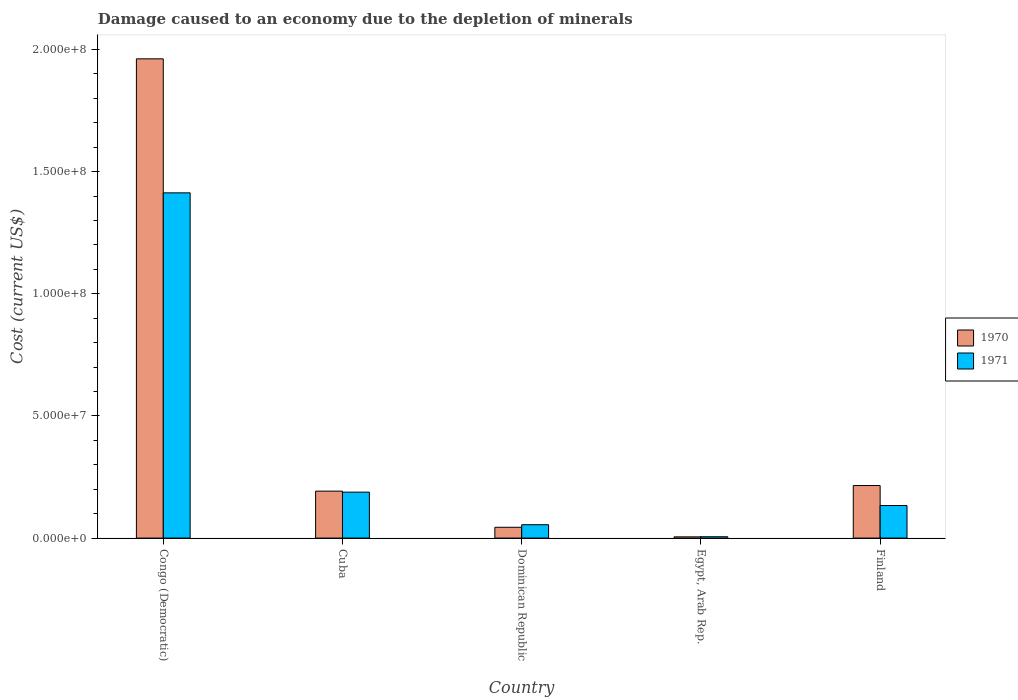Are the number of bars per tick equal to the number of legend labels?
Provide a succinct answer. Yes. Are the number of bars on each tick of the X-axis equal?
Ensure brevity in your answer.  Yes. How many bars are there on the 5th tick from the left?
Keep it short and to the point. 2. How many bars are there on the 2nd tick from the right?
Your answer should be very brief. 2. What is the label of the 5th group of bars from the left?
Ensure brevity in your answer.  Finland. What is the cost of damage caused due to the depletion of minerals in 1970 in Egypt, Arab Rep.?
Your answer should be compact. 5.07e+05. Across all countries, what is the maximum cost of damage caused due to the depletion of minerals in 1971?
Your response must be concise. 1.41e+08. Across all countries, what is the minimum cost of damage caused due to the depletion of minerals in 1970?
Your answer should be very brief. 5.07e+05. In which country was the cost of damage caused due to the depletion of minerals in 1971 maximum?
Make the answer very short. Congo (Democratic). In which country was the cost of damage caused due to the depletion of minerals in 1970 minimum?
Ensure brevity in your answer.  Egypt, Arab Rep. What is the total cost of damage caused due to the depletion of minerals in 1971 in the graph?
Provide a succinct answer. 1.79e+08. What is the difference between the cost of damage caused due to the depletion of minerals in 1970 in Cuba and that in Egypt, Arab Rep.?
Your answer should be compact. 1.87e+07. What is the difference between the cost of damage caused due to the depletion of minerals in 1971 in Congo (Democratic) and the cost of damage caused due to the depletion of minerals in 1970 in Egypt, Arab Rep.?
Ensure brevity in your answer.  1.41e+08. What is the average cost of damage caused due to the depletion of minerals in 1970 per country?
Make the answer very short. 4.84e+07. What is the difference between the cost of damage caused due to the depletion of minerals of/in 1970 and cost of damage caused due to the depletion of minerals of/in 1971 in Egypt, Arab Rep.?
Your answer should be very brief. -4.79e+04. What is the ratio of the cost of damage caused due to the depletion of minerals in 1970 in Egypt, Arab Rep. to that in Finland?
Offer a very short reply. 0.02. Is the cost of damage caused due to the depletion of minerals in 1971 in Congo (Democratic) less than that in Dominican Republic?
Your answer should be compact. No. What is the difference between the highest and the second highest cost of damage caused due to the depletion of minerals in 1971?
Make the answer very short. -1.28e+08. What is the difference between the highest and the lowest cost of damage caused due to the depletion of minerals in 1970?
Keep it short and to the point. 1.96e+08. Is the sum of the cost of damage caused due to the depletion of minerals in 1971 in Congo (Democratic) and Cuba greater than the maximum cost of damage caused due to the depletion of minerals in 1970 across all countries?
Provide a succinct answer. No. How many bars are there?
Offer a terse response. 10. What is the difference between two consecutive major ticks on the Y-axis?
Give a very brief answer. 5.00e+07. What is the title of the graph?
Your response must be concise. Damage caused to an economy due to the depletion of minerals. What is the label or title of the X-axis?
Your response must be concise. Country. What is the label or title of the Y-axis?
Give a very brief answer. Cost (current US$). What is the Cost (current US$) of 1970 in Congo (Democratic)?
Your answer should be compact. 1.96e+08. What is the Cost (current US$) of 1971 in Congo (Democratic)?
Ensure brevity in your answer.  1.41e+08. What is the Cost (current US$) of 1970 in Cuba?
Provide a succinct answer. 1.92e+07. What is the Cost (current US$) of 1971 in Cuba?
Give a very brief answer. 1.88e+07. What is the Cost (current US$) of 1970 in Dominican Republic?
Offer a terse response. 4.43e+06. What is the Cost (current US$) of 1971 in Dominican Republic?
Give a very brief answer. 5.48e+06. What is the Cost (current US$) of 1970 in Egypt, Arab Rep.?
Offer a very short reply. 5.07e+05. What is the Cost (current US$) in 1971 in Egypt, Arab Rep.?
Provide a succinct answer. 5.55e+05. What is the Cost (current US$) of 1970 in Finland?
Ensure brevity in your answer.  2.15e+07. What is the Cost (current US$) of 1971 in Finland?
Your response must be concise. 1.33e+07. Across all countries, what is the maximum Cost (current US$) of 1970?
Make the answer very short. 1.96e+08. Across all countries, what is the maximum Cost (current US$) in 1971?
Your answer should be very brief. 1.41e+08. Across all countries, what is the minimum Cost (current US$) of 1970?
Offer a terse response. 5.07e+05. Across all countries, what is the minimum Cost (current US$) in 1971?
Your answer should be very brief. 5.55e+05. What is the total Cost (current US$) in 1970 in the graph?
Provide a short and direct response. 2.42e+08. What is the total Cost (current US$) of 1971 in the graph?
Your answer should be compact. 1.79e+08. What is the difference between the Cost (current US$) of 1970 in Congo (Democratic) and that in Cuba?
Make the answer very short. 1.77e+08. What is the difference between the Cost (current US$) in 1971 in Congo (Democratic) and that in Cuba?
Offer a terse response. 1.23e+08. What is the difference between the Cost (current US$) of 1970 in Congo (Democratic) and that in Dominican Republic?
Make the answer very short. 1.92e+08. What is the difference between the Cost (current US$) in 1971 in Congo (Democratic) and that in Dominican Republic?
Make the answer very short. 1.36e+08. What is the difference between the Cost (current US$) of 1970 in Congo (Democratic) and that in Egypt, Arab Rep.?
Make the answer very short. 1.96e+08. What is the difference between the Cost (current US$) in 1971 in Congo (Democratic) and that in Egypt, Arab Rep.?
Provide a short and direct response. 1.41e+08. What is the difference between the Cost (current US$) in 1970 in Congo (Democratic) and that in Finland?
Your response must be concise. 1.75e+08. What is the difference between the Cost (current US$) of 1971 in Congo (Democratic) and that in Finland?
Your answer should be compact. 1.28e+08. What is the difference between the Cost (current US$) of 1970 in Cuba and that in Dominican Republic?
Offer a terse response. 1.48e+07. What is the difference between the Cost (current US$) in 1971 in Cuba and that in Dominican Republic?
Your response must be concise. 1.33e+07. What is the difference between the Cost (current US$) of 1970 in Cuba and that in Egypt, Arab Rep.?
Provide a succinct answer. 1.87e+07. What is the difference between the Cost (current US$) of 1971 in Cuba and that in Egypt, Arab Rep.?
Offer a terse response. 1.83e+07. What is the difference between the Cost (current US$) of 1970 in Cuba and that in Finland?
Give a very brief answer. -2.30e+06. What is the difference between the Cost (current US$) of 1971 in Cuba and that in Finland?
Keep it short and to the point. 5.48e+06. What is the difference between the Cost (current US$) in 1970 in Dominican Republic and that in Egypt, Arab Rep.?
Keep it short and to the point. 3.92e+06. What is the difference between the Cost (current US$) of 1971 in Dominican Republic and that in Egypt, Arab Rep.?
Make the answer very short. 4.92e+06. What is the difference between the Cost (current US$) of 1970 in Dominican Republic and that in Finland?
Your response must be concise. -1.71e+07. What is the difference between the Cost (current US$) of 1971 in Dominican Republic and that in Finland?
Provide a short and direct response. -7.85e+06. What is the difference between the Cost (current US$) of 1970 in Egypt, Arab Rep. and that in Finland?
Your answer should be very brief. -2.10e+07. What is the difference between the Cost (current US$) in 1971 in Egypt, Arab Rep. and that in Finland?
Your response must be concise. -1.28e+07. What is the difference between the Cost (current US$) of 1970 in Congo (Democratic) and the Cost (current US$) of 1971 in Cuba?
Offer a terse response. 1.77e+08. What is the difference between the Cost (current US$) of 1970 in Congo (Democratic) and the Cost (current US$) of 1971 in Dominican Republic?
Ensure brevity in your answer.  1.91e+08. What is the difference between the Cost (current US$) of 1970 in Congo (Democratic) and the Cost (current US$) of 1971 in Egypt, Arab Rep.?
Give a very brief answer. 1.96e+08. What is the difference between the Cost (current US$) of 1970 in Congo (Democratic) and the Cost (current US$) of 1971 in Finland?
Your answer should be compact. 1.83e+08. What is the difference between the Cost (current US$) of 1970 in Cuba and the Cost (current US$) of 1971 in Dominican Republic?
Your answer should be compact. 1.37e+07. What is the difference between the Cost (current US$) in 1970 in Cuba and the Cost (current US$) in 1971 in Egypt, Arab Rep.?
Offer a terse response. 1.87e+07. What is the difference between the Cost (current US$) of 1970 in Cuba and the Cost (current US$) of 1971 in Finland?
Ensure brevity in your answer.  5.90e+06. What is the difference between the Cost (current US$) of 1970 in Dominican Republic and the Cost (current US$) of 1971 in Egypt, Arab Rep.?
Provide a succinct answer. 3.87e+06. What is the difference between the Cost (current US$) in 1970 in Dominican Republic and the Cost (current US$) in 1971 in Finland?
Provide a short and direct response. -8.90e+06. What is the difference between the Cost (current US$) in 1970 in Egypt, Arab Rep. and the Cost (current US$) in 1971 in Finland?
Provide a short and direct response. -1.28e+07. What is the average Cost (current US$) of 1970 per country?
Provide a short and direct response. 4.84e+07. What is the average Cost (current US$) of 1971 per country?
Provide a short and direct response. 3.59e+07. What is the difference between the Cost (current US$) of 1970 and Cost (current US$) of 1971 in Congo (Democratic)?
Give a very brief answer. 5.49e+07. What is the difference between the Cost (current US$) in 1970 and Cost (current US$) in 1971 in Cuba?
Offer a very short reply. 4.14e+05. What is the difference between the Cost (current US$) of 1970 and Cost (current US$) of 1971 in Dominican Republic?
Offer a terse response. -1.05e+06. What is the difference between the Cost (current US$) of 1970 and Cost (current US$) of 1971 in Egypt, Arab Rep.?
Make the answer very short. -4.79e+04. What is the difference between the Cost (current US$) of 1970 and Cost (current US$) of 1971 in Finland?
Your answer should be very brief. 8.20e+06. What is the ratio of the Cost (current US$) of 1970 in Congo (Democratic) to that in Cuba?
Your answer should be very brief. 10.21. What is the ratio of the Cost (current US$) of 1971 in Congo (Democratic) to that in Cuba?
Offer a very short reply. 7.51. What is the ratio of the Cost (current US$) in 1970 in Congo (Democratic) to that in Dominican Republic?
Provide a short and direct response. 44.31. What is the ratio of the Cost (current US$) of 1971 in Congo (Democratic) to that in Dominican Republic?
Your answer should be compact. 25.8. What is the ratio of the Cost (current US$) of 1970 in Congo (Democratic) to that in Egypt, Arab Rep.?
Give a very brief answer. 386.71. What is the ratio of the Cost (current US$) of 1971 in Congo (Democratic) to that in Egypt, Arab Rep.?
Provide a short and direct response. 254.55. What is the ratio of the Cost (current US$) in 1970 in Congo (Democratic) to that in Finland?
Give a very brief answer. 9.12. What is the ratio of the Cost (current US$) of 1971 in Congo (Democratic) to that in Finland?
Provide a short and direct response. 10.61. What is the ratio of the Cost (current US$) in 1970 in Cuba to that in Dominican Republic?
Give a very brief answer. 4.34. What is the ratio of the Cost (current US$) of 1971 in Cuba to that in Dominican Republic?
Make the answer very short. 3.43. What is the ratio of the Cost (current US$) in 1970 in Cuba to that in Egypt, Arab Rep.?
Your answer should be compact. 37.89. What is the ratio of the Cost (current US$) of 1971 in Cuba to that in Egypt, Arab Rep.?
Make the answer very short. 33.88. What is the ratio of the Cost (current US$) in 1970 in Cuba to that in Finland?
Offer a terse response. 0.89. What is the ratio of the Cost (current US$) in 1971 in Cuba to that in Finland?
Offer a terse response. 1.41. What is the ratio of the Cost (current US$) in 1970 in Dominican Republic to that in Egypt, Arab Rep.?
Provide a succinct answer. 8.73. What is the ratio of the Cost (current US$) in 1971 in Dominican Republic to that in Egypt, Arab Rep.?
Offer a terse response. 9.87. What is the ratio of the Cost (current US$) of 1970 in Dominican Republic to that in Finland?
Offer a very short reply. 0.21. What is the ratio of the Cost (current US$) in 1971 in Dominican Republic to that in Finland?
Give a very brief answer. 0.41. What is the ratio of the Cost (current US$) of 1970 in Egypt, Arab Rep. to that in Finland?
Your answer should be very brief. 0.02. What is the ratio of the Cost (current US$) of 1971 in Egypt, Arab Rep. to that in Finland?
Provide a succinct answer. 0.04. What is the difference between the highest and the second highest Cost (current US$) in 1970?
Your response must be concise. 1.75e+08. What is the difference between the highest and the second highest Cost (current US$) in 1971?
Your answer should be compact. 1.23e+08. What is the difference between the highest and the lowest Cost (current US$) in 1970?
Offer a very short reply. 1.96e+08. What is the difference between the highest and the lowest Cost (current US$) of 1971?
Keep it short and to the point. 1.41e+08. 